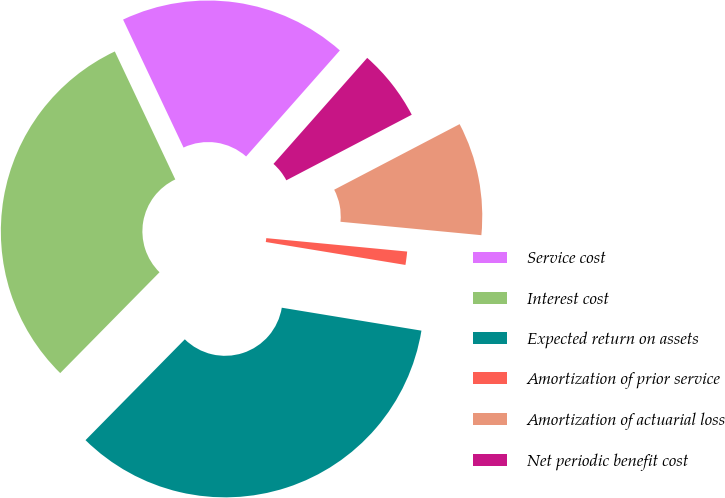Convert chart to OTSL. <chart><loc_0><loc_0><loc_500><loc_500><pie_chart><fcel>Service cost<fcel>Interest cost<fcel>Expected return on assets<fcel>Amortization of prior service<fcel>Amortization of actuarial loss<fcel>Net periodic benefit cost<nl><fcel>18.55%<fcel>30.6%<fcel>34.79%<fcel>1.08%<fcel>9.18%<fcel>5.81%<nl></chart> 